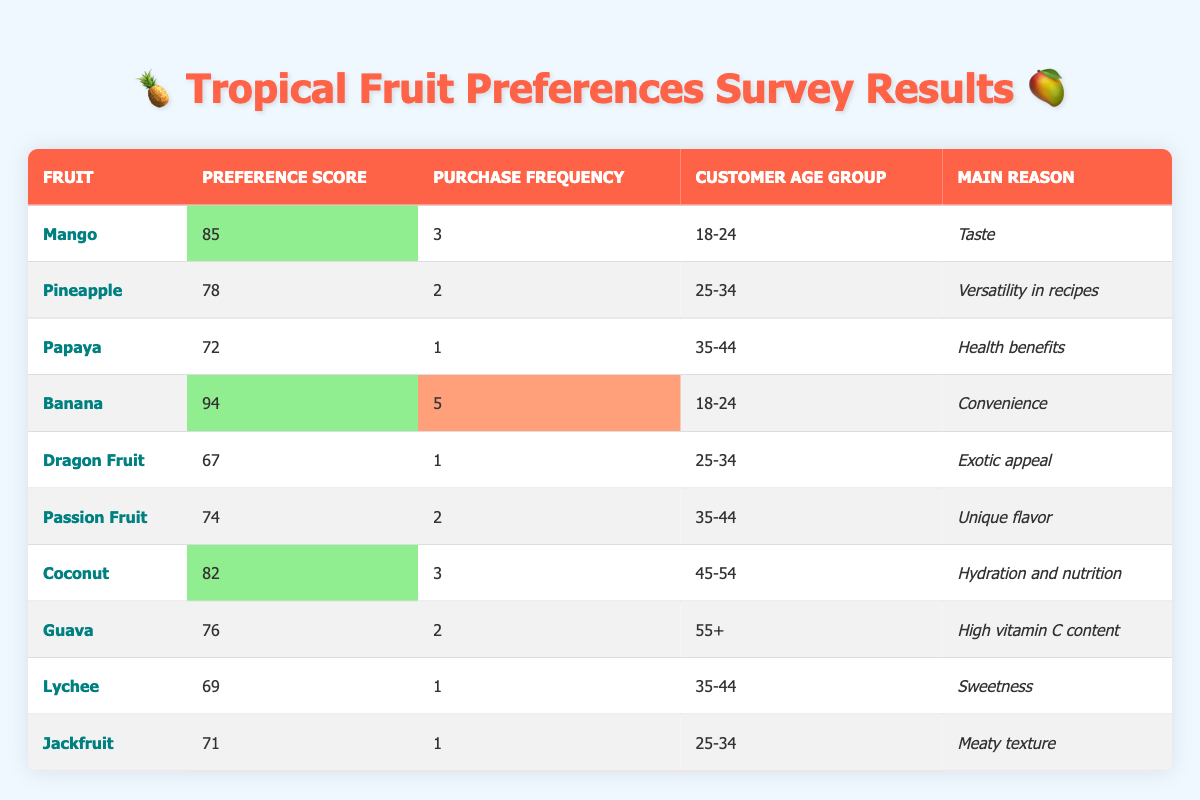What fruit has the highest preference score? By scanning the "Preference Score" column, the highest value is 94, which corresponds to the fruit Banana.
Answer: Banana What is the main reason customers prefer Mango? Looking at the "Main Reason" column for Mango, the reason provided is "Taste."
Answer: Taste How many times a week do customers in the age group "18-24" purchase Banana? The "Purchase Frequency" for Banana in the age group "18-24" is 5, indicating customers purchase it five times a week.
Answer: 5 What is the preference score for Pineapple? The table shows that Pineapple has a preference score of 78 as indicated in the "Preference Score" column.
Answer: 78 Is the main reason for choosing Coconut related to hydration? The main reason for Coconut in the table is "Hydration and nutrition," which confirms it is related to hydration.
Answer: Yes How many fruits have a preference score higher than 75? The fruits with preference scores higher than 75 are Mango (85), Banana (94), Coconut (82), and Guava (76), totaling four fruits.
Answer: 4 Which age group has the highest purchase frequency on average? The purchase frequencies for the age groups are: 18-24 (4), 25-34 (1.33), 35-44 (1), 45-54 (3), 55+ (2). The average for 18-24 is the highest at 5.
Answer: 18-24 What is the difference in preference scores between Mango and Papaya? The preference score for Mango is 85 and for Papaya is 72. The difference is 85 - 72 = 13.
Answer: 13 How many fruits are preferred by the age group "35-44"? The fruits preferred by the age group "35-44" are Papaya, Passion Fruit, and Lychee, making a total of three fruits.
Answer: 3 What age group primarily prefers Dragon Fruit? Checking the "Customer Age Group" column for Dragon Fruit, it falls under the "25-34" age group.
Answer: 25-34 Which fruit has the lowest preference score and what is the reason? Dragon Fruit has the lowest preference score of 67, and its main reason listed is "Exotic appeal."
Answer: Dragon Fruit, Exotic appeal How does the purchase frequency of Guava compare to that of Passion Fruit? Guava has a purchase frequency of 2, while Passion Fruit also has a purchase frequency of 2, indicating they are the same.
Answer: Same (2) If a customer aged 45-54 buys Coconut 3 times a week, how does this compare to the highest purchase frequency? Coconut's purchase frequency of 3 is lower than the highest frequency of Banana at 5.
Answer: Lower Based on the table, which fruit in the 55+ age group has the highest preference score? Guava is the only fruit listed for the 55+ age group, and it has a preference score of 76.
Answer: Guava 